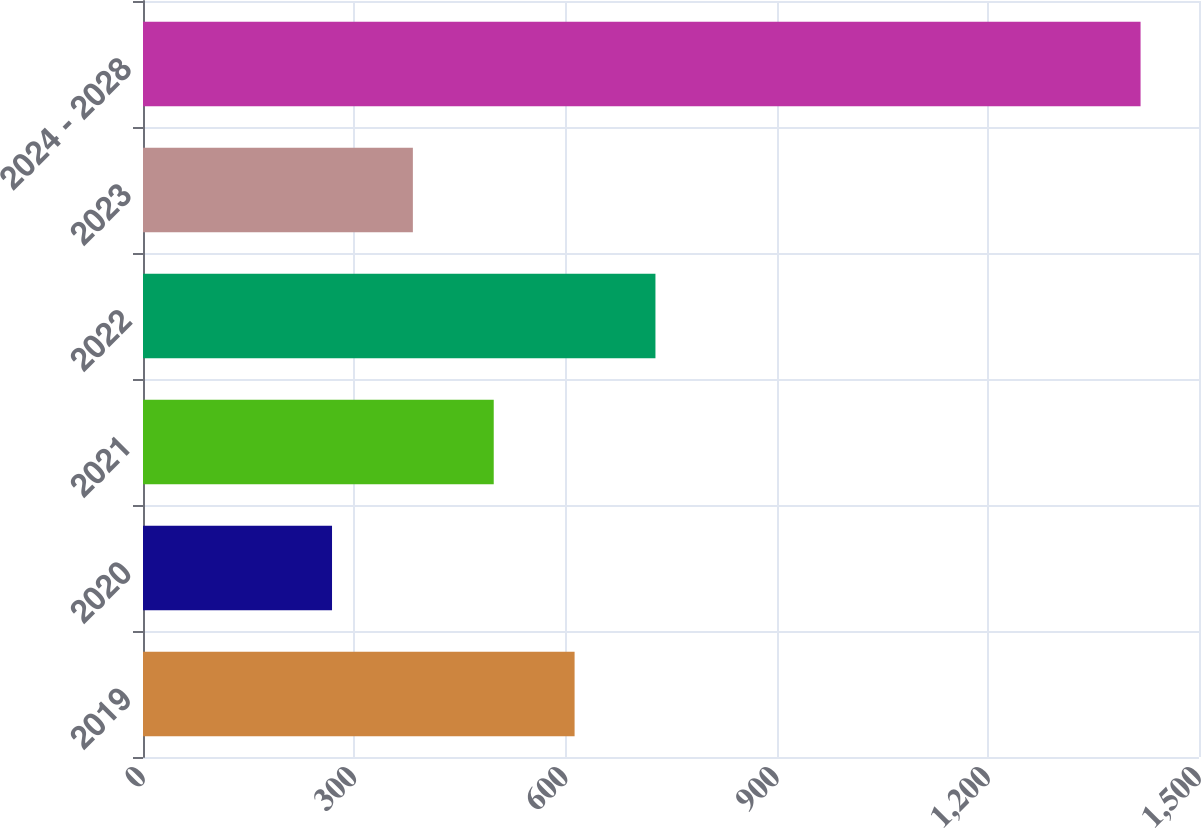Convert chart. <chart><loc_0><loc_0><loc_500><loc_500><bar_chart><fcel>2019<fcel>2020<fcel>2021<fcel>2022<fcel>2023<fcel>2024 - 2028<nl><fcel>613.05<fcel>268.5<fcel>498.2<fcel>727.9<fcel>383.35<fcel>1417<nl></chart> 